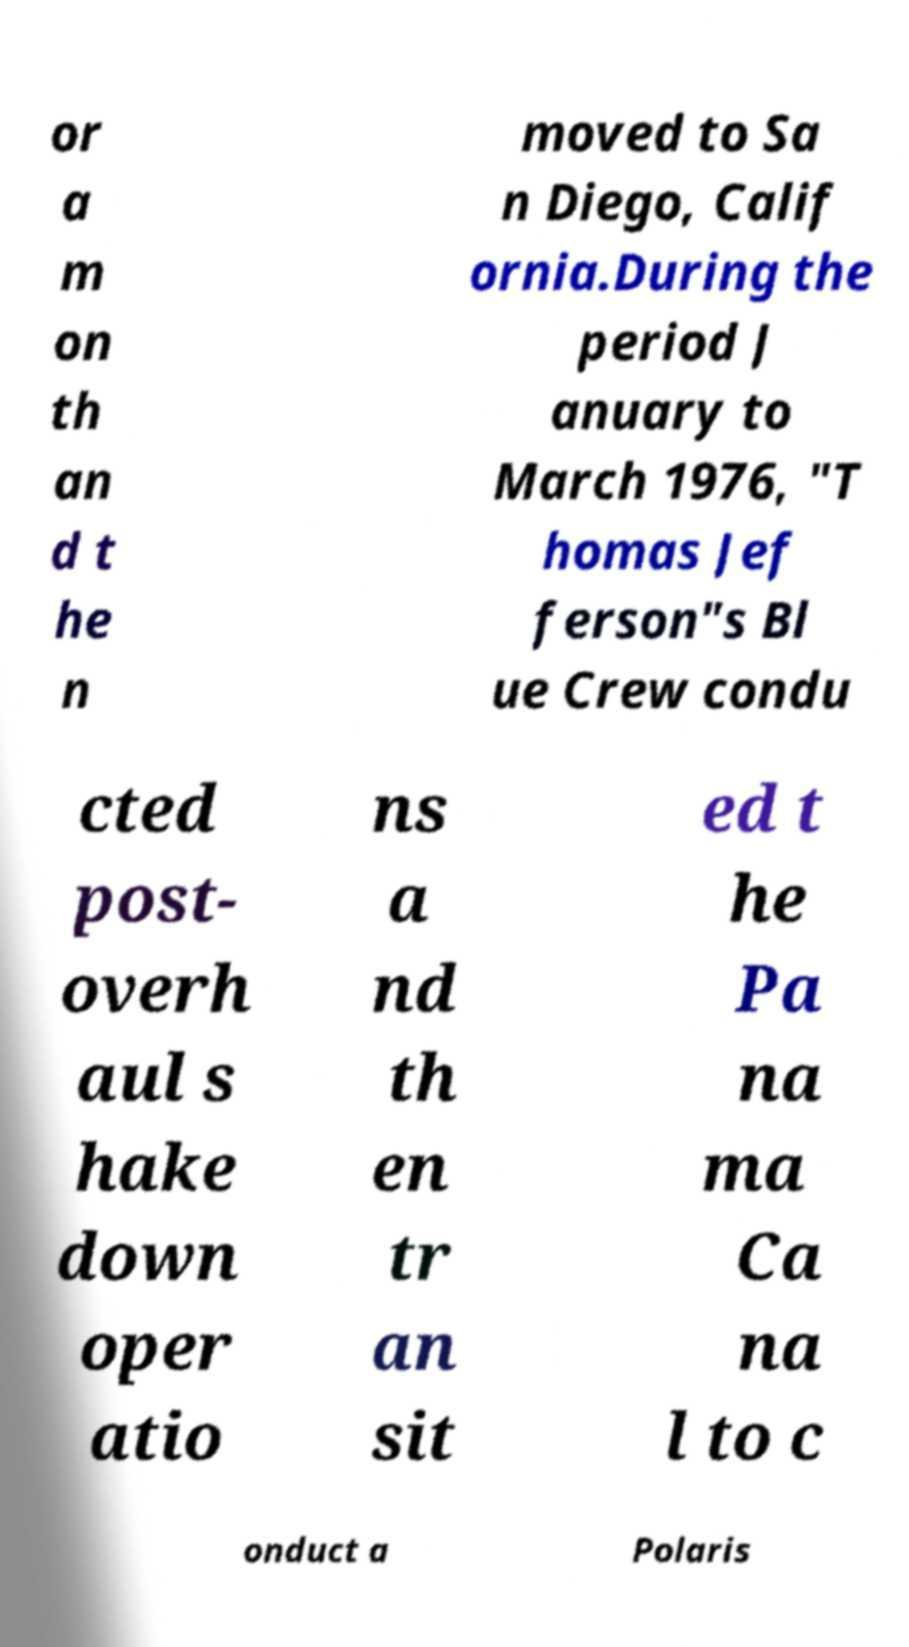Could you assist in decoding the text presented in this image and type it out clearly? or a m on th an d t he n moved to Sa n Diego, Calif ornia.During the period J anuary to March 1976, "T homas Jef ferson"s Bl ue Crew condu cted post- overh aul s hake down oper atio ns a nd th en tr an sit ed t he Pa na ma Ca na l to c onduct a Polaris 